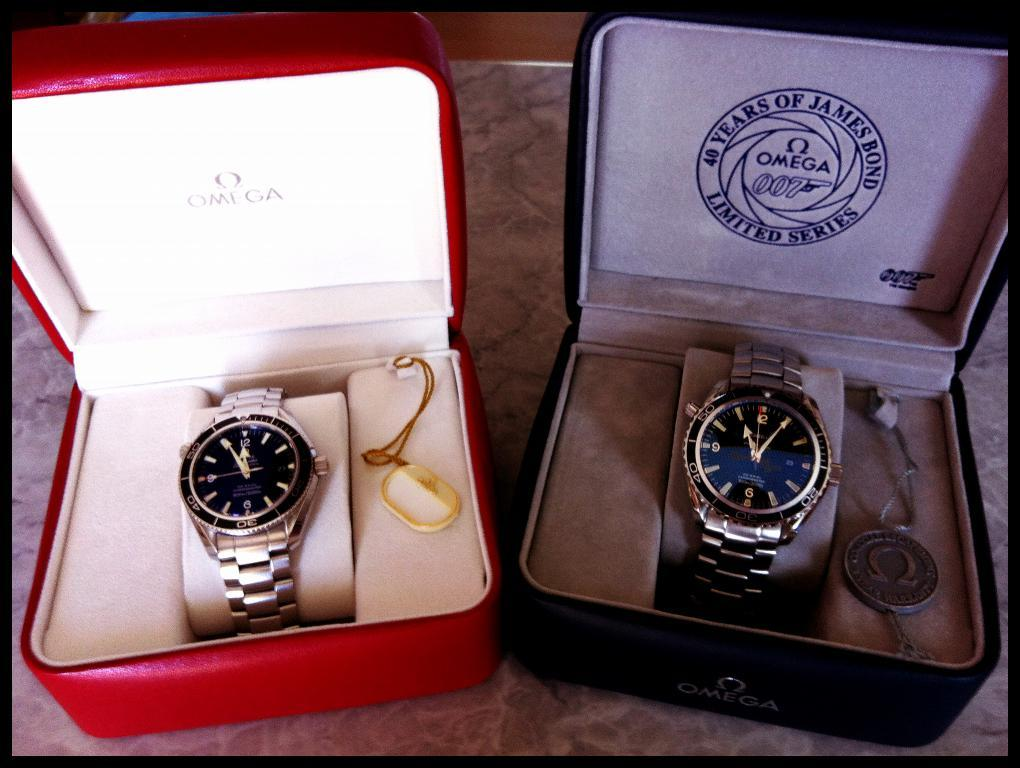<image>
Describe the image concisely. Two watches are side by side in boxes, one of which is from the brand Omega. 